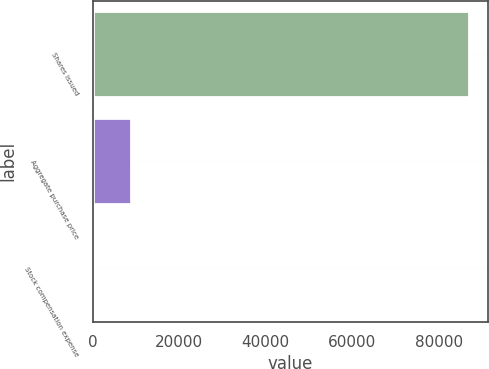<chart> <loc_0><loc_0><loc_500><loc_500><bar_chart><fcel>Shares issued<fcel>Aggregate purchase price<fcel>Stock compensation expense<nl><fcel>87000<fcel>8700.36<fcel>0.4<nl></chart> 